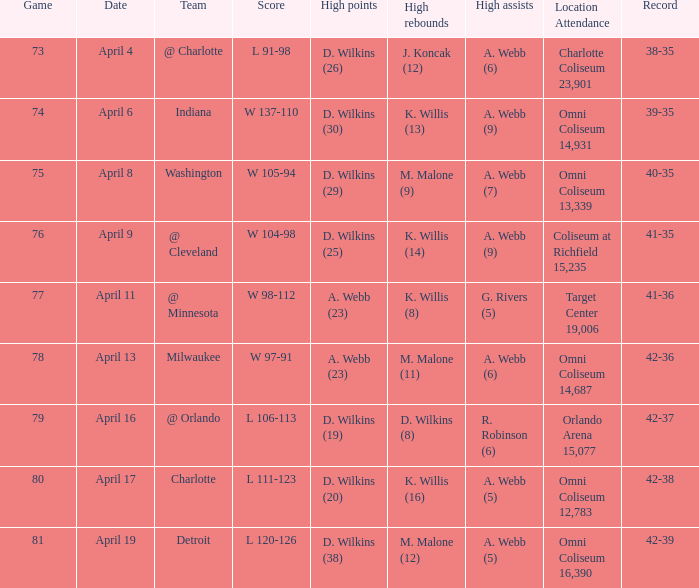When did g. rivers (5) record the most assists in a single game? April 11. 